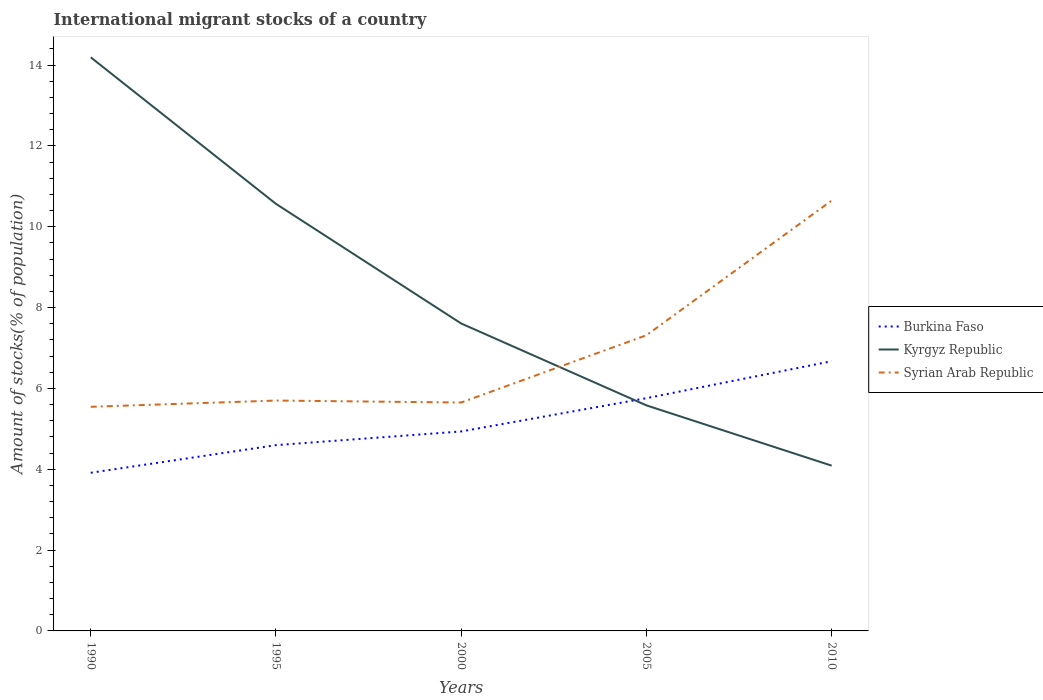Does the line corresponding to Kyrgyz Republic intersect with the line corresponding to Burkina Faso?
Provide a short and direct response. Yes. Across all years, what is the maximum amount of stocks in in Syrian Arab Republic?
Your answer should be compact. 5.54. In which year was the amount of stocks in in Kyrgyz Republic maximum?
Give a very brief answer. 2010. What is the total amount of stocks in in Syrian Arab Republic in the graph?
Give a very brief answer. -5. What is the difference between the highest and the second highest amount of stocks in in Kyrgyz Republic?
Your answer should be very brief. 10.1. How many lines are there?
Keep it short and to the point. 3. Are the values on the major ticks of Y-axis written in scientific E-notation?
Your answer should be compact. No. Does the graph contain any zero values?
Your answer should be very brief. No. Where does the legend appear in the graph?
Ensure brevity in your answer.  Center right. How many legend labels are there?
Offer a very short reply. 3. How are the legend labels stacked?
Provide a succinct answer. Vertical. What is the title of the graph?
Ensure brevity in your answer.  International migrant stocks of a country. Does "Djibouti" appear as one of the legend labels in the graph?
Ensure brevity in your answer.  No. What is the label or title of the Y-axis?
Provide a short and direct response. Amount of stocks(% of population). What is the Amount of stocks(% of population) in Burkina Faso in 1990?
Keep it short and to the point. 3.91. What is the Amount of stocks(% of population) of Kyrgyz Republic in 1990?
Give a very brief answer. 14.19. What is the Amount of stocks(% of population) in Syrian Arab Republic in 1990?
Keep it short and to the point. 5.54. What is the Amount of stocks(% of population) in Burkina Faso in 1995?
Your answer should be very brief. 4.6. What is the Amount of stocks(% of population) of Kyrgyz Republic in 1995?
Offer a very short reply. 10.56. What is the Amount of stocks(% of population) in Syrian Arab Republic in 1995?
Offer a terse response. 5.7. What is the Amount of stocks(% of population) of Burkina Faso in 2000?
Make the answer very short. 4.93. What is the Amount of stocks(% of population) of Kyrgyz Republic in 2000?
Your response must be concise. 7.61. What is the Amount of stocks(% of population) of Syrian Arab Republic in 2000?
Your answer should be very brief. 5.65. What is the Amount of stocks(% of population) of Burkina Faso in 2005?
Make the answer very short. 5.76. What is the Amount of stocks(% of population) in Kyrgyz Republic in 2005?
Provide a short and direct response. 5.58. What is the Amount of stocks(% of population) in Syrian Arab Republic in 2005?
Make the answer very short. 7.31. What is the Amount of stocks(% of population) of Burkina Faso in 2010?
Make the answer very short. 6.67. What is the Amount of stocks(% of population) in Kyrgyz Republic in 2010?
Offer a terse response. 4.09. What is the Amount of stocks(% of population) in Syrian Arab Republic in 2010?
Keep it short and to the point. 10.65. Across all years, what is the maximum Amount of stocks(% of population) in Burkina Faso?
Provide a succinct answer. 6.67. Across all years, what is the maximum Amount of stocks(% of population) in Kyrgyz Republic?
Your response must be concise. 14.19. Across all years, what is the maximum Amount of stocks(% of population) of Syrian Arab Republic?
Give a very brief answer. 10.65. Across all years, what is the minimum Amount of stocks(% of population) of Burkina Faso?
Your answer should be very brief. 3.91. Across all years, what is the minimum Amount of stocks(% of population) of Kyrgyz Republic?
Your response must be concise. 4.09. Across all years, what is the minimum Amount of stocks(% of population) of Syrian Arab Republic?
Your answer should be very brief. 5.54. What is the total Amount of stocks(% of population) of Burkina Faso in the graph?
Ensure brevity in your answer.  25.87. What is the total Amount of stocks(% of population) in Kyrgyz Republic in the graph?
Provide a succinct answer. 42.03. What is the total Amount of stocks(% of population) in Syrian Arab Republic in the graph?
Your response must be concise. 34.85. What is the difference between the Amount of stocks(% of population) in Burkina Faso in 1990 and that in 1995?
Make the answer very short. -0.68. What is the difference between the Amount of stocks(% of population) in Kyrgyz Republic in 1990 and that in 1995?
Provide a succinct answer. 3.62. What is the difference between the Amount of stocks(% of population) in Syrian Arab Republic in 1990 and that in 1995?
Your answer should be very brief. -0.15. What is the difference between the Amount of stocks(% of population) in Burkina Faso in 1990 and that in 2000?
Your answer should be compact. -1.02. What is the difference between the Amount of stocks(% of population) of Kyrgyz Republic in 1990 and that in 2000?
Make the answer very short. 6.58. What is the difference between the Amount of stocks(% of population) in Syrian Arab Republic in 1990 and that in 2000?
Offer a very short reply. -0.11. What is the difference between the Amount of stocks(% of population) of Burkina Faso in 1990 and that in 2005?
Offer a terse response. -1.85. What is the difference between the Amount of stocks(% of population) of Kyrgyz Republic in 1990 and that in 2005?
Give a very brief answer. 8.61. What is the difference between the Amount of stocks(% of population) in Syrian Arab Republic in 1990 and that in 2005?
Make the answer very short. -1.77. What is the difference between the Amount of stocks(% of population) of Burkina Faso in 1990 and that in 2010?
Your response must be concise. -2.76. What is the difference between the Amount of stocks(% of population) in Kyrgyz Republic in 1990 and that in 2010?
Your answer should be compact. 10.1. What is the difference between the Amount of stocks(% of population) of Syrian Arab Republic in 1990 and that in 2010?
Offer a very short reply. -5.1. What is the difference between the Amount of stocks(% of population) of Burkina Faso in 1995 and that in 2000?
Offer a very short reply. -0.34. What is the difference between the Amount of stocks(% of population) in Kyrgyz Republic in 1995 and that in 2000?
Provide a short and direct response. 2.96. What is the difference between the Amount of stocks(% of population) in Syrian Arab Republic in 1995 and that in 2000?
Ensure brevity in your answer.  0.05. What is the difference between the Amount of stocks(% of population) in Burkina Faso in 1995 and that in 2005?
Offer a terse response. -1.16. What is the difference between the Amount of stocks(% of population) of Kyrgyz Republic in 1995 and that in 2005?
Your response must be concise. 4.99. What is the difference between the Amount of stocks(% of population) of Syrian Arab Republic in 1995 and that in 2005?
Keep it short and to the point. -1.62. What is the difference between the Amount of stocks(% of population) of Burkina Faso in 1995 and that in 2010?
Keep it short and to the point. -2.08. What is the difference between the Amount of stocks(% of population) in Kyrgyz Republic in 1995 and that in 2010?
Ensure brevity in your answer.  6.48. What is the difference between the Amount of stocks(% of population) of Syrian Arab Republic in 1995 and that in 2010?
Offer a terse response. -4.95. What is the difference between the Amount of stocks(% of population) of Burkina Faso in 2000 and that in 2005?
Offer a terse response. -0.82. What is the difference between the Amount of stocks(% of population) in Kyrgyz Republic in 2000 and that in 2005?
Your answer should be very brief. 2.03. What is the difference between the Amount of stocks(% of population) of Syrian Arab Republic in 2000 and that in 2005?
Make the answer very short. -1.66. What is the difference between the Amount of stocks(% of population) of Burkina Faso in 2000 and that in 2010?
Ensure brevity in your answer.  -1.74. What is the difference between the Amount of stocks(% of population) of Kyrgyz Republic in 2000 and that in 2010?
Offer a terse response. 3.52. What is the difference between the Amount of stocks(% of population) in Syrian Arab Republic in 2000 and that in 2010?
Your answer should be compact. -5. What is the difference between the Amount of stocks(% of population) in Burkina Faso in 2005 and that in 2010?
Keep it short and to the point. -0.91. What is the difference between the Amount of stocks(% of population) of Kyrgyz Republic in 2005 and that in 2010?
Ensure brevity in your answer.  1.49. What is the difference between the Amount of stocks(% of population) of Syrian Arab Republic in 2005 and that in 2010?
Provide a short and direct response. -3.33. What is the difference between the Amount of stocks(% of population) in Burkina Faso in 1990 and the Amount of stocks(% of population) in Kyrgyz Republic in 1995?
Offer a very short reply. -6.65. What is the difference between the Amount of stocks(% of population) of Burkina Faso in 1990 and the Amount of stocks(% of population) of Syrian Arab Republic in 1995?
Provide a short and direct response. -1.79. What is the difference between the Amount of stocks(% of population) of Kyrgyz Republic in 1990 and the Amount of stocks(% of population) of Syrian Arab Republic in 1995?
Your answer should be compact. 8.49. What is the difference between the Amount of stocks(% of population) in Burkina Faso in 1990 and the Amount of stocks(% of population) in Kyrgyz Republic in 2000?
Make the answer very short. -3.69. What is the difference between the Amount of stocks(% of population) of Burkina Faso in 1990 and the Amount of stocks(% of population) of Syrian Arab Republic in 2000?
Offer a very short reply. -1.74. What is the difference between the Amount of stocks(% of population) in Kyrgyz Republic in 1990 and the Amount of stocks(% of population) in Syrian Arab Republic in 2000?
Offer a terse response. 8.54. What is the difference between the Amount of stocks(% of population) in Burkina Faso in 1990 and the Amount of stocks(% of population) in Kyrgyz Republic in 2005?
Make the answer very short. -1.67. What is the difference between the Amount of stocks(% of population) of Burkina Faso in 1990 and the Amount of stocks(% of population) of Syrian Arab Republic in 2005?
Ensure brevity in your answer.  -3.4. What is the difference between the Amount of stocks(% of population) of Kyrgyz Republic in 1990 and the Amount of stocks(% of population) of Syrian Arab Republic in 2005?
Make the answer very short. 6.87. What is the difference between the Amount of stocks(% of population) in Burkina Faso in 1990 and the Amount of stocks(% of population) in Kyrgyz Republic in 2010?
Offer a very short reply. -0.18. What is the difference between the Amount of stocks(% of population) in Burkina Faso in 1990 and the Amount of stocks(% of population) in Syrian Arab Republic in 2010?
Offer a very short reply. -6.73. What is the difference between the Amount of stocks(% of population) of Kyrgyz Republic in 1990 and the Amount of stocks(% of population) of Syrian Arab Republic in 2010?
Your answer should be very brief. 3.54. What is the difference between the Amount of stocks(% of population) of Burkina Faso in 1995 and the Amount of stocks(% of population) of Kyrgyz Republic in 2000?
Give a very brief answer. -3.01. What is the difference between the Amount of stocks(% of population) in Burkina Faso in 1995 and the Amount of stocks(% of population) in Syrian Arab Republic in 2000?
Provide a succinct answer. -1.05. What is the difference between the Amount of stocks(% of population) in Kyrgyz Republic in 1995 and the Amount of stocks(% of population) in Syrian Arab Republic in 2000?
Give a very brief answer. 4.91. What is the difference between the Amount of stocks(% of population) in Burkina Faso in 1995 and the Amount of stocks(% of population) in Kyrgyz Republic in 2005?
Your response must be concise. -0.98. What is the difference between the Amount of stocks(% of population) in Burkina Faso in 1995 and the Amount of stocks(% of population) in Syrian Arab Republic in 2005?
Keep it short and to the point. -2.72. What is the difference between the Amount of stocks(% of population) in Kyrgyz Republic in 1995 and the Amount of stocks(% of population) in Syrian Arab Republic in 2005?
Keep it short and to the point. 3.25. What is the difference between the Amount of stocks(% of population) in Burkina Faso in 1995 and the Amount of stocks(% of population) in Kyrgyz Republic in 2010?
Offer a terse response. 0.51. What is the difference between the Amount of stocks(% of population) of Burkina Faso in 1995 and the Amount of stocks(% of population) of Syrian Arab Republic in 2010?
Offer a terse response. -6.05. What is the difference between the Amount of stocks(% of population) of Kyrgyz Republic in 1995 and the Amount of stocks(% of population) of Syrian Arab Republic in 2010?
Provide a short and direct response. -0.08. What is the difference between the Amount of stocks(% of population) of Burkina Faso in 2000 and the Amount of stocks(% of population) of Kyrgyz Republic in 2005?
Provide a succinct answer. -0.64. What is the difference between the Amount of stocks(% of population) of Burkina Faso in 2000 and the Amount of stocks(% of population) of Syrian Arab Republic in 2005?
Provide a short and direct response. -2.38. What is the difference between the Amount of stocks(% of population) in Kyrgyz Republic in 2000 and the Amount of stocks(% of population) in Syrian Arab Republic in 2005?
Provide a succinct answer. 0.29. What is the difference between the Amount of stocks(% of population) in Burkina Faso in 2000 and the Amount of stocks(% of population) in Kyrgyz Republic in 2010?
Give a very brief answer. 0.85. What is the difference between the Amount of stocks(% of population) in Burkina Faso in 2000 and the Amount of stocks(% of population) in Syrian Arab Republic in 2010?
Your response must be concise. -5.71. What is the difference between the Amount of stocks(% of population) in Kyrgyz Republic in 2000 and the Amount of stocks(% of population) in Syrian Arab Republic in 2010?
Give a very brief answer. -3.04. What is the difference between the Amount of stocks(% of population) in Burkina Faso in 2005 and the Amount of stocks(% of population) in Kyrgyz Republic in 2010?
Offer a very short reply. 1.67. What is the difference between the Amount of stocks(% of population) in Burkina Faso in 2005 and the Amount of stocks(% of population) in Syrian Arab Republic in 2010?
Offer a terse response. -4.89. What is the difference between the Amount of stocks(% of population) in Kyrgyz Republic in 2005 and the Amount of stocks(% of population) in Syrian Arab Republic in 2010?
Provide a succinct answer. -5.07. What is the average Amount of stocks(% of population) of Burkina Faso per year?
Provide a succinct answer. 5.17. What is the average Amount of stocks(% of population) in Kyrgyz Republic per year?
Make the answer very short. 8.41. What is the average Amount of stocks(% of population) of Syrian Arab Republic per year?
Your answer should be compact. 6.97. In the year 1990, what is the difference between the Amount of stocks(% of population) in Burkina Faso and Amount of stocks(% of population) in Kyrgyz Republic?
Offer a terse response. -10.28. In the year 1990, what is the difference between the Amount of stocks(% of population) in Burkina Faso and Amount of stocks(% of population) in Syrian Arab Republic?
Offer a terse response. -1.63. In the year 1990, what is the difference between the Amount of stocks(% of population) in Kyrgyz Republic and Amount of stocks(% of population) in Syrian Arab Republic?
Your answer should be very brief. 8.65. In the year 1995, what is the difference between the Amount of stocks(% of population) in Burkina Faso and Amount of stocks(% of population) in Kyrgyz Republic?
Provide a succinct answer. -5.97. In the year 1995, what is the difference between the Amount of stocks(% of population) of Burkina Faso and Amount of stocks(% of population) of Syrian Arab Republic?
Offer a very short reply. -1.1. In the year 1995, what is the difference between the Amount of stocks(% of population) of Kyrgyz Republic and Amount of stocks(% of population) of Syrian Arab Republic?
Make the answer very short. 4.87. In the year 2000, what is the difference between the Amount of stocks(% of population) of Burkina Faso and Amount of stocks(% of population) of Kyrgyz Republic?
Your response must be concise. -2.67. In the year 2000, what is the difference between the Amount of stocks(% of population) of Burkina Faso and Amount of stocks(% of population) of Syrian Arab Republic?
Offer a terse response. -0.72. In the year 2000, what is the difference between the Amount of stocks(% of population) in Kyrgyz Republic and Amount of stocks(% of population) in Syrian Arab Republic?
Keep it short and to the point. 1.95. In the year 2005, what is the difference between the Amount of stocks(% of population) in Burkina Faso and Amount of stocks(% of population) in Kyrgyz Republic?
Your answer should be very brief. 0.18. In the year 2005, what is the difference between the Amount of stocks(% of population) in Burkina Faso and Amount of stocks(% of population) in Syrian Arab Republic?
Provide a short and direct response. -1.56. In the year 2005, what is the difference between the Amount of stocks(% of population) of Kyrgyz Republic and Amount of stocks(% of population) of Syrian Arab Republic?
Provide a succinct answer. -1.74. In the year 2010, what is the difference between the Amount of stocks(% of population) of Burkina Faso and Amount of stocks(% of population) of Kyrgyz Republic?
Provide a short and direct response. 2.58. In the year 2010, what is the difference between the Amount of stocks(% of population) in Burkina Faso and Amount of stocks(% of population) in Syrian Arab Republic?
Make the answer very short. -3.97. In the year 2010, what is the difference between the Amount of stocks(% of population) of Kyrgyz Republic and Amount of stocks(% of population) of Syrian Arab Republic?
Your answer should be very brief. -6.56. What is the ratio of the Amount of stocks(% of population) in Burkina Faso in 1990 to that in 1995?
Offer a very short reply. 0.85. What is the ratio of the Amount of stocks(% of population) in Kyrgyz Republic in 1990 to that in 1995?
Offer a very short reply. 1.34. What is the ratio of the Amount of stocks(% of population) in Syrian Arab Republic in 1990 to that in 1995?
Your response must be concise. 0.97. What is the ratio of the Amount of stocks(% of population) of Burkina Faso in 1990 to that in 2000?
Provide a succinct answer. 0.79. What is the ratio of the Amount of stocks(% of population) in Kyrgyz Republic in 1990 to that in 2000?
Provide a short and direct response. 1.87. What is the ratio of the Amount of stocks(% of population) of Syrian Arab Republic in 1990 to that in 2000?
Your response must be concise. 0.98. What is the ratio of the Amount of stocks(% of population) in Burkina Faso in 1990 to that in 2005?
Give a very brief answer. 0.68. What is the ratio of the Amount of stocks(% of population) in Kyrgyz Republic in 1990 to that in 2005?
Your response must be concise. 2.54. What is the ratio of the Amount of stocks(% of population) in Syrian Arab Republic in 1990 to that in 2005?
Keep it short and to the point. 0.76. What is the ratio of the Amount of stocks(% of population) in Burkina Faso in 1990 to that in 2010?
Make the answer very short. 0.59. What is the ratio of the Amount of stocks(% of population) of Kyrgyz Republic in 1990 to that in 2010?
Your answer should be compact. 3.47. What is the ratio of the Amount of stocks(% of population) of Syrian Arab Republic in 1990 to that in 2010?
Ensure brevity in your answer.  0.52. What is the ratio of the Amount of stocks(% of population) of Burkina Faso in 1995 to that in 2000?
Provide a short and direct response. 0.93. What is the ratio of the Amount of stocks(% of population) in Kyrgyz Republic in 1995 to that in 2000?
Provide a short and direct response. 1.39. What is the ratio of the Amount of stocks(% of population) in Syrian Arab Republic in 1995 to that in 2000?
Offer a terse response. 1.01. What is the ratio of the Amount of stocks(% of population) in Burkina Faso in 1995 to that in 2005?
Offer a terse response. 0.8. What is the ratio of the Amount of stocks(% of population) of Kyrgyz Republic in 1995 to that in 2005?
Offer a very short reply. 1.89. What is the ratio of the Amount of stocks(% of population) in Syrian Arab Republic in 1995 to that in 2005?
Keep it short and to the point. 0.78. What is the ratio of the Amount of stocks(% of population) in Burkina Faso in 1995 to that in 2010?
Keep it short and to the point. 0.69. What is the ratio of the Amount of stocks(% of population) of Kyrgyz Republic in 1995 to that in 2010?
Your answer should be compact. 2.58. What is the ratio of the Amount of stocks(% of population) of Syrian Arab Republic in 1995 to that in 2010?
Provide a short and direct response. 0.54. What is the ratio of the Amount of stocks(% of population) of Burkina Faso in 2000 to that in 2005?
Your answer should be compact. 0.86. What is the ratio of the Amount of stocks(% of population) of Kyrgyz Republic in 2000 to that in 2005?
Your answer should be compact. 1.36. What is the ratio of the Amount of stocks(% of population) in Syrian Arab Republic in 2000 to that in 2005?
Your response must be concise. 0.77. What is the ratio of the Amount of stocks(% of population) of Burkina Faso in 2000 to that in 2010?
Provide a succinct answer. 0.74. What is the ratio of the Amount of stocks(% of population) in Kyrgyz Republic in 2000 to that in 2010?
Make the answer very short. 1.86. What is the ratio of the Amount of stocks(% of population) in Syrian Arab Republic in 2000 to that in 2010?
Make the answer very short. 0.53. What is the ratio of the Amount of stocks(% of population) in Burkina Faso in 2005 to that in 2010?
Keep it short and to the point. 0.86. What is the ratio of the Amount of stocks(% of population) of Kyrgyz Republic in 2005 to that in 2010?
Offer a terse response. 1.36. What is the ratio of the Amount of stocks(% of population) of Syrian Arab Republic in 2005 to that in 2010?
Keep it short and to the point. 0.69. What is the difference between the highest and the second highest Amount of stocks(% of population) in Burkina Faso?
Keep it short and to the point. 0.91. What is the difference between the highest and the second highest Amount of stocks(% of population) of Kyrgyz Republic?
Make the answer very short. 3.62. What is the difference between the highest and the second highest Amount of stocks(% of population) in Syrian Arab Republic?
Make the answer very short. 3.33. What is the difference between the highest and the lowest Amount of stocks(% of population) of Burkina Faso?
Keep it short and to the point. 2.76. What is the difference between the highest and the lowest Amount of stocks(% of population) of Kyrgyz Republic?
Keep it short and to the point. 10.1. What is the difference between the highest and the lowest Amount of stocks(% of population) of Syrian Arab Republic?
Ensure brevity in your answer.  5.1. 